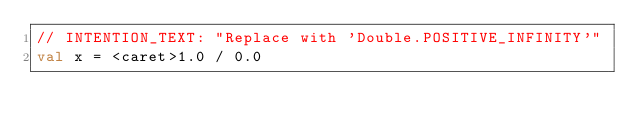Convert code to text. <code><loc_0><loc_0><loc_500><loc_500><_Kotlin_>// INTENTION_TEXT: "Replace with 'Double.POSITIVE_INFINITY'"
val x = <caret>1.0 / 0.0</code> 